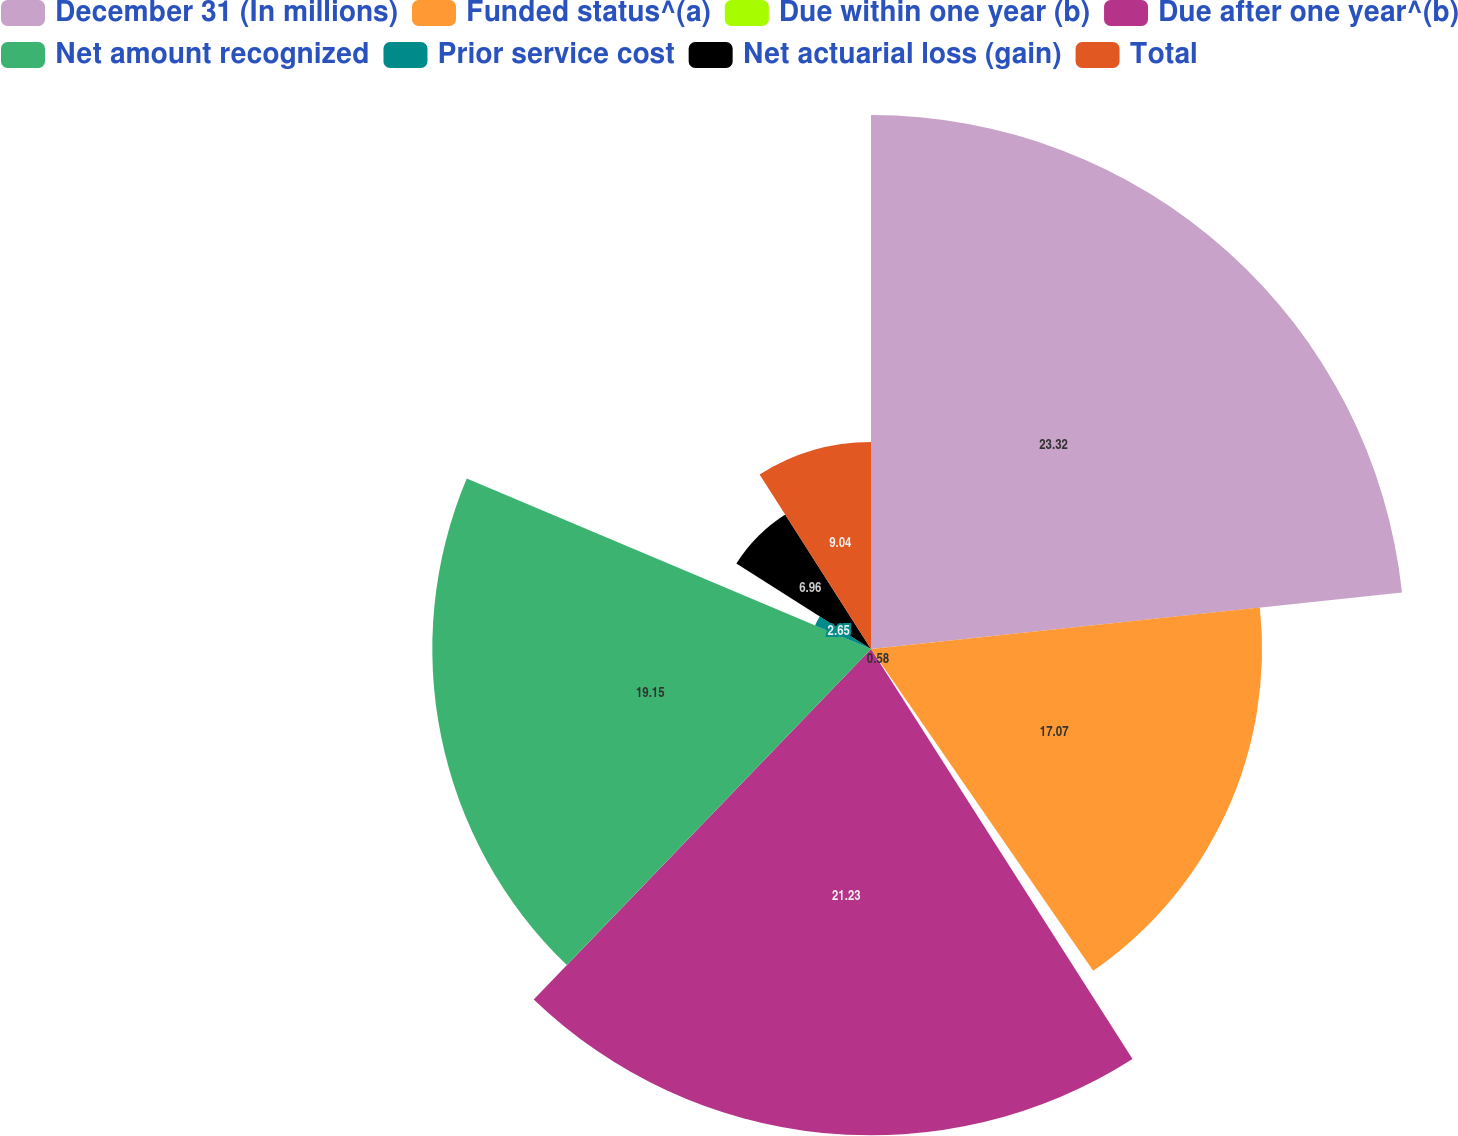<chart> <loc_0><loc_0><loc_500><loc_500><pie_chart><fcel>December 31 (In millions)<fcel>Funded status^(a)<fcel>Due within one year (b)<fcel>Due after one year^(b)<fcel>Net amount recognized<fcel>Prior service cost<fcel>Net actuarial loss (gain)<fcel>Total<nl><fcel>23.31%<fcel>17.07%<fcel>0.58%<fcel>21.23%<fcel>19.15%<fcel>2.65%<fcel>6.96%<fcel>9.04%<nl></chart> 